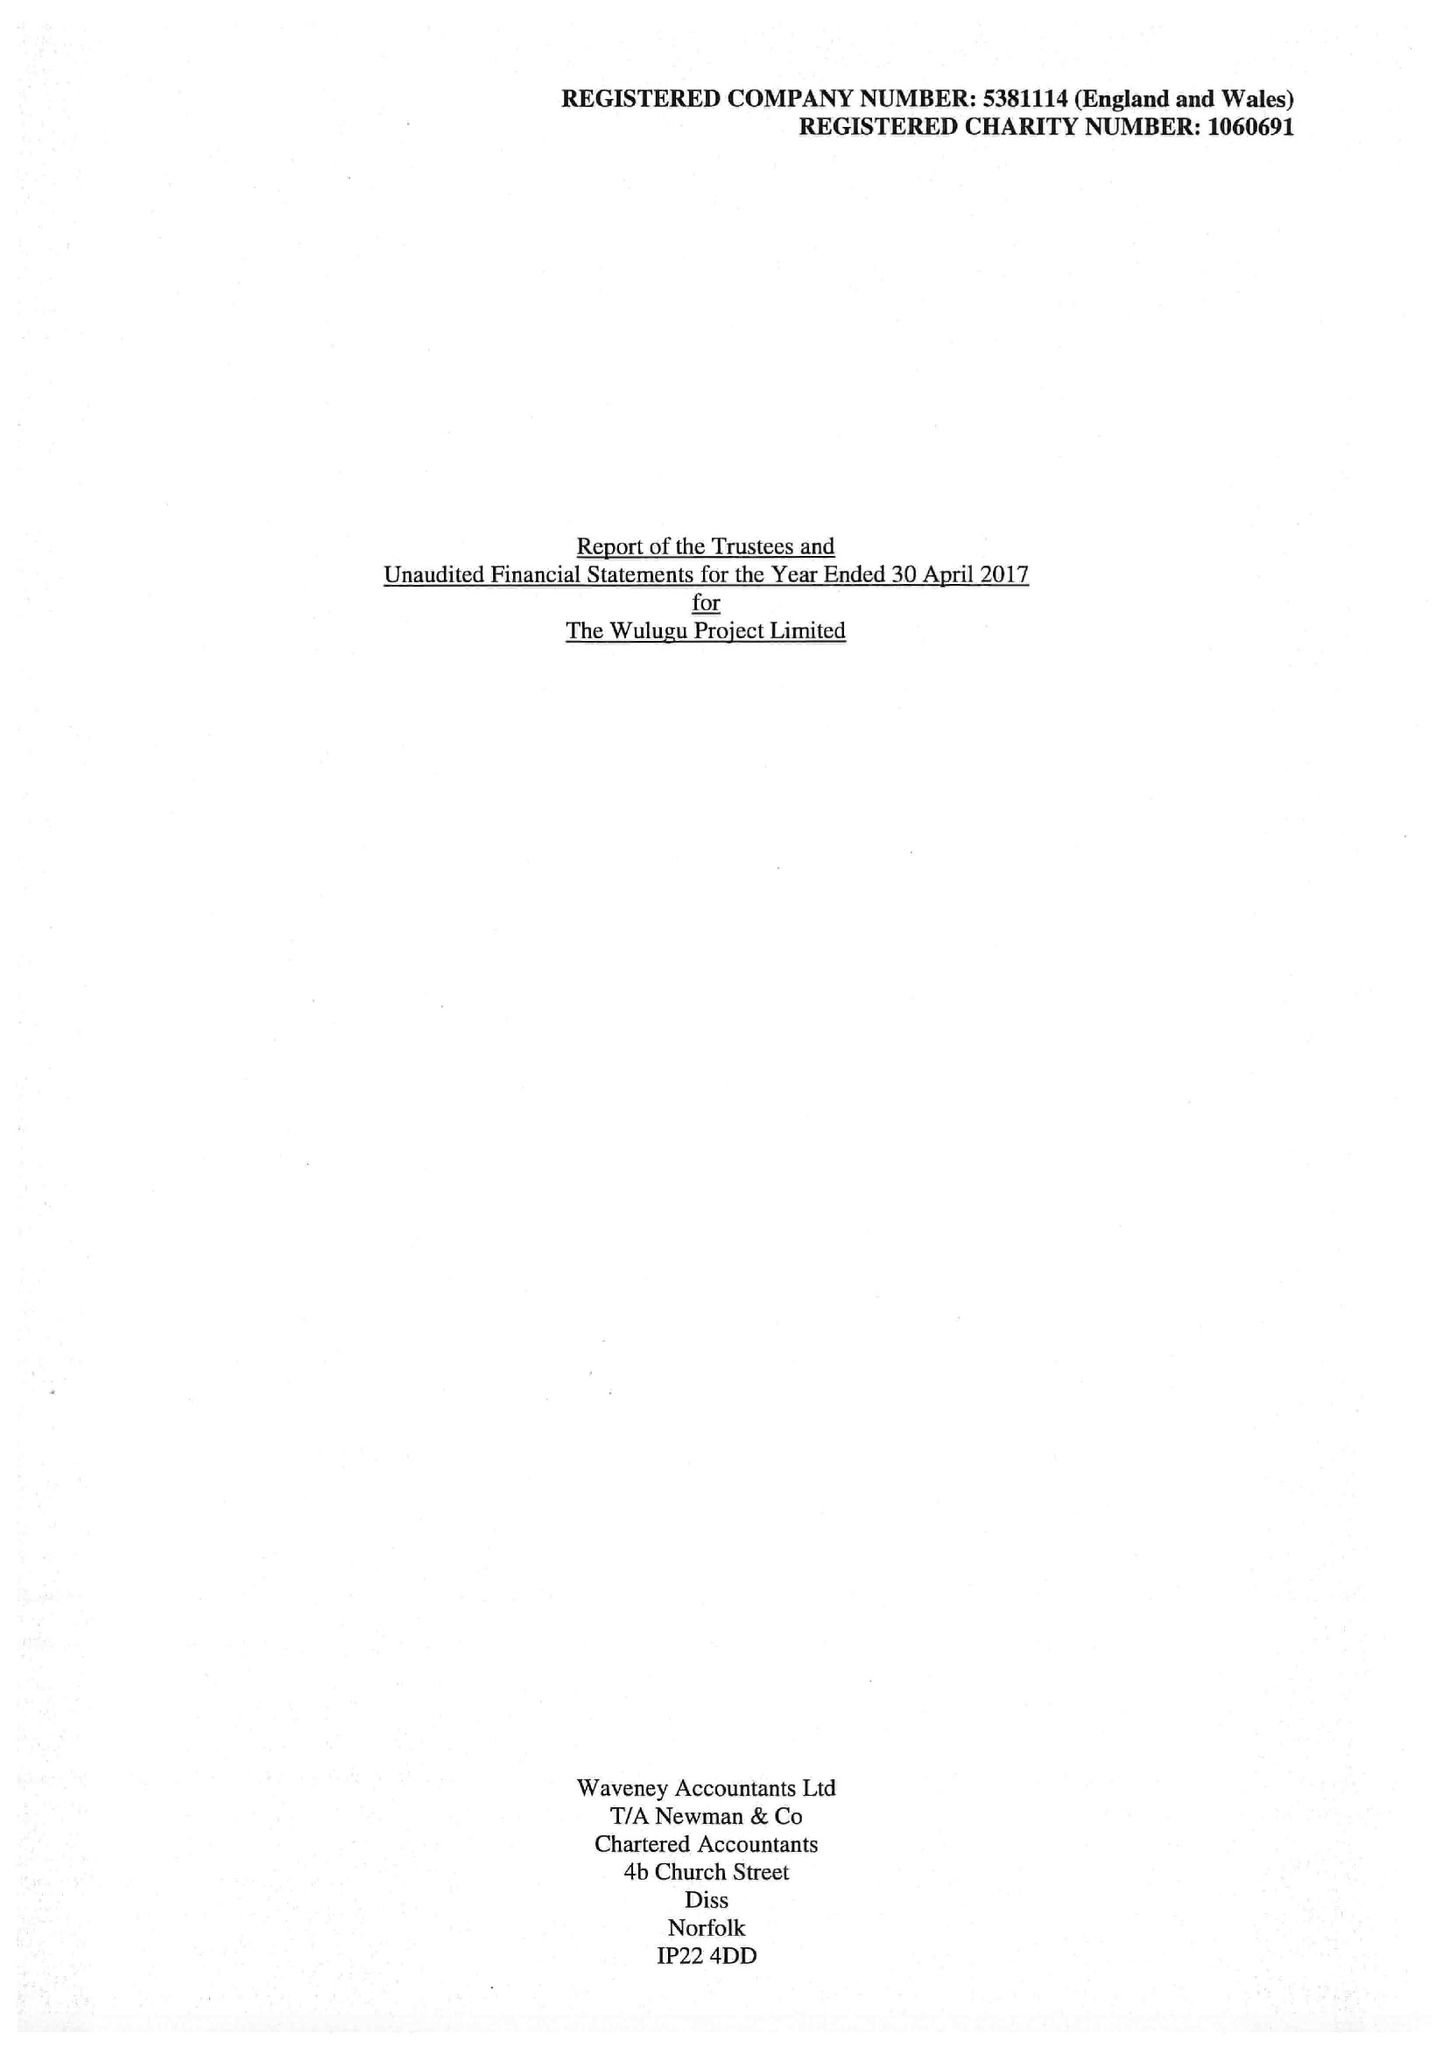What is the value for the address__street_line?
Answer the question using a single word or phrase. CHURCH FARM 